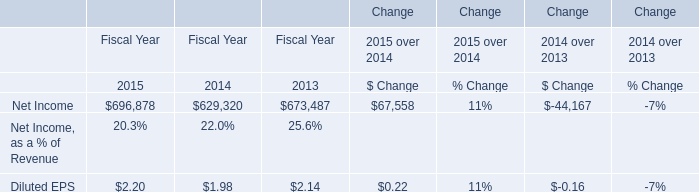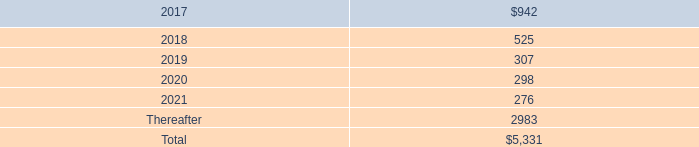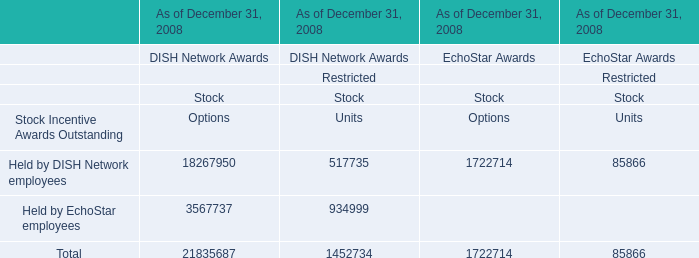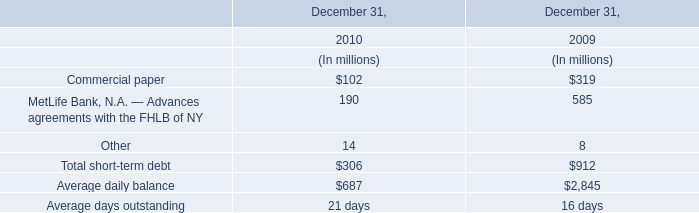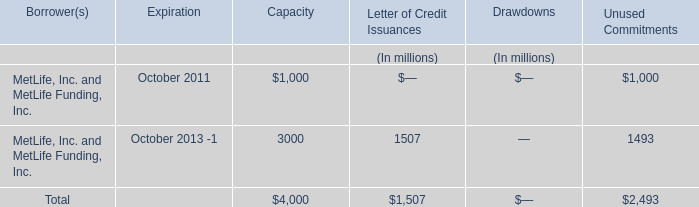considering the total unconditional purchase obligations , what is the percentage of helium purchases concerning the total value? 
Computations: (4000 / 5331)
Answer: 0.75033. 